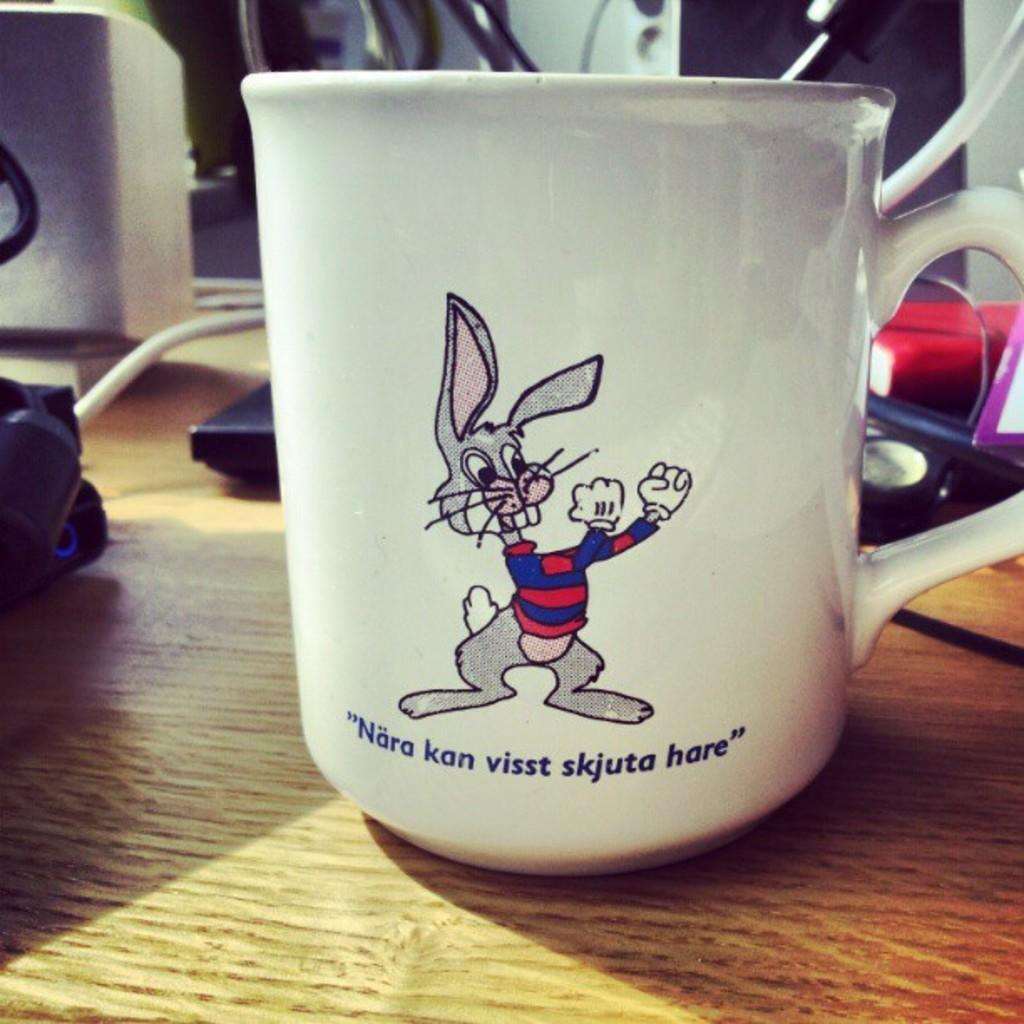<image>
Give a short and clear explanation of the subsequent image. a cup that had a bunny and the word nara on it 